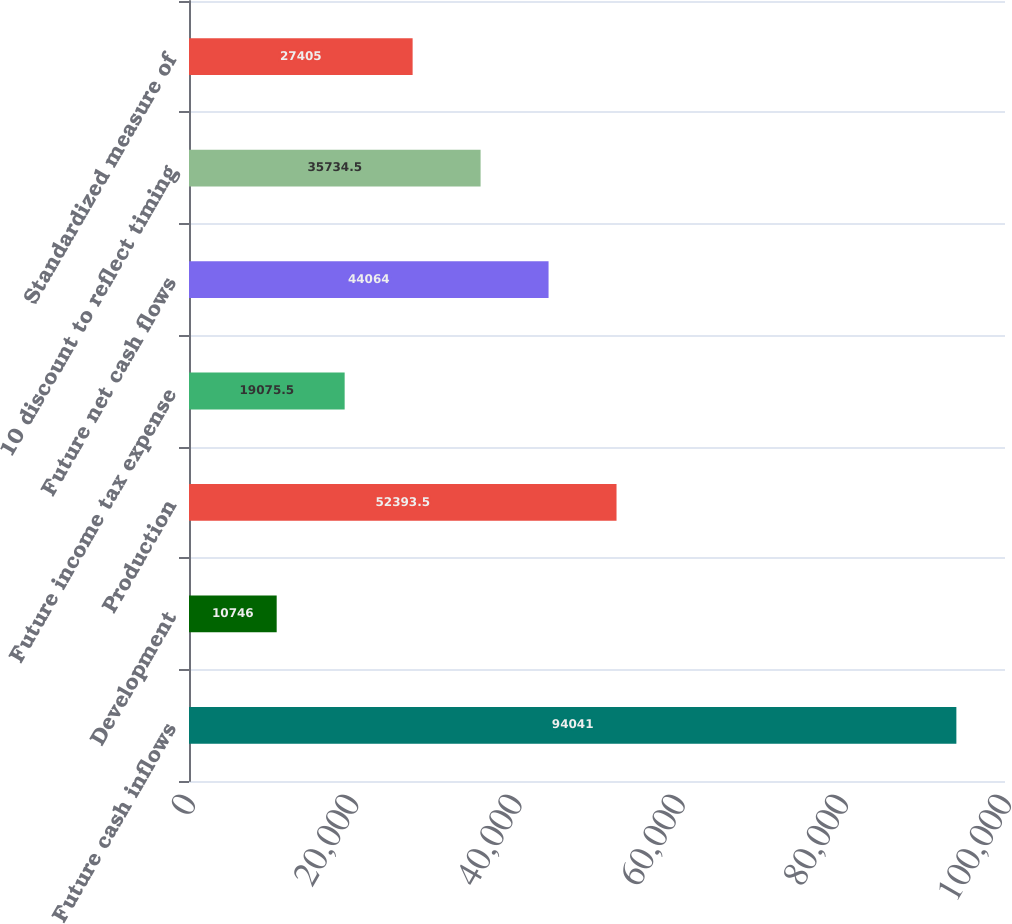<chart> <loc_0><loc_0><loc_500><loc_500><bar_chart><fcel>Future cash inflows<fcel>Development<fcel>Production<fcel>Future income tax expense<fcel>Future net cash flows<fcel>10 discount to reflect timing<fcel>Standardized measure of<nl><fcel>94041<fcel>10746<fcel>52393.5<fcel>19075.5<fcel>44064<fcel>35734.5<fcel>27405<nl></chart> 